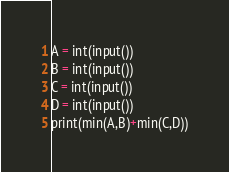Convert code to text. <code><loc_0><loc_0><loc_500><loc_500><_Python_>A = int(input())
B = int(input())
C = int(input())
D = int(input())
print(min(A,B)+min(C,D))</code> 